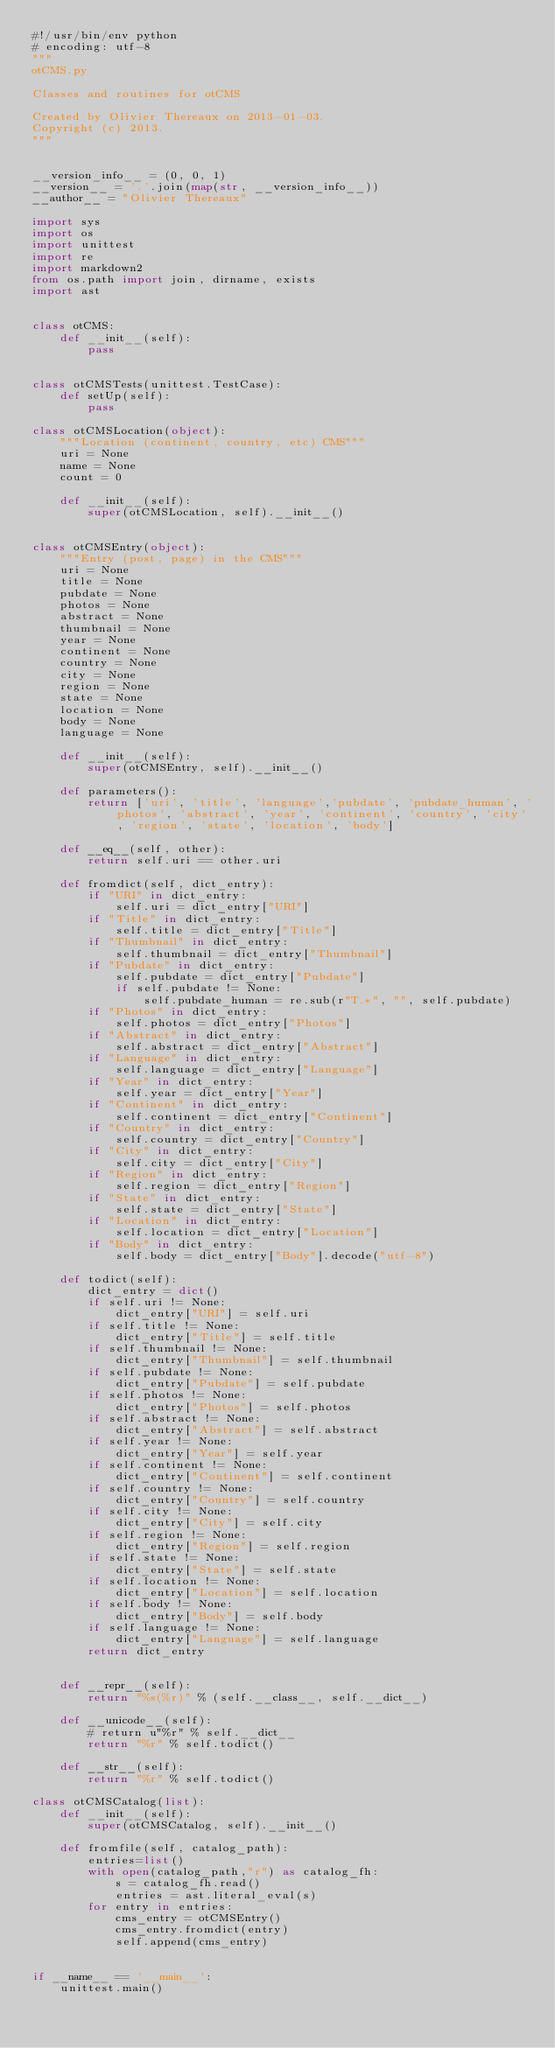Convert code to text. <code><loc_0><loc_0><loc_500><loc_500><_Python_>#!/usr/bin/env python
# encoding: utf-8
"""
otCMS.py

Classes and routines for otCMS

Created by Olivier Thereaux on 2013-01-03.
Copyright (c) 2013.
"""


__version_info__ = (0, 0, 1)
__version__ = '.'.join(map(str, __version_info__))
__author__ = "Olivier Thereaux"

import sys
import os
import unittest
import re
import markdown2
from os.path import join, dirname, exists
import ast


class otCMS:
    def __init__(self):
        pass


class otCMSTests(unittest.TestCase):
    def setUp(self):
        pass

class otCMSLocation(object):
    """Location (continent, country, etc) CMS"""
    uri = None
    name = None
    count = 0

    def __init__(self):
        super(otCMSLocation, self).__init__()


class otCMSEntry(object):
    """Entry (post, page) in the CMS"""
    uri = None
    title = None
    pubdate = None
    photos = None
    abstract = None
    thumbnail = None
    year = None
    continent = None
    country = None
    city = None
    region = None
    state = None
    location = None
    body = None
    language = None

    def __init__(self):
        super(otCMSEntry, self).__init__()

    def parameters():
        return ['uri', 'title', 'language','pubdate', 'pubdate_human', 'photos', 'abstract', 'year', 'continent', 'country', 'city', 'region', 'state', 'location', 'body']

    def __eq__(self, other):
        return self.uri == other.uri

    def fromdict(self, dict_entry):
        if "URI" in dict_entry:
            self.uri = dict_entry["URI"]
        if "Title" in dict_entry:
            self.title = dict_entry["Title"]
        if "Thumbnail" in dict_entry:
            self.thumbnail = dict_entry["Thumbnail"]
        if "Pubdate" in dict_entry:
            self.pubdate = dict_entry["Pubdate"]
            if self.pubdate != None:
                self.pubdate_human = re.sub(r"T.*", "", self.pubdate)
        if "Photos" in dict_entry:
            self.photos = dict_entry["Photos"]
        if "Abstract" in dict_entry:
            self.abstract = dict_entry["Abstract"]
        if "Language" in dict_entry:
            self.language = dict_entry["Language"]
        if "Year" in dict_entry:
            self.year = dict_entry["Year"]
        if "Continent" in dict_entry:
            self.continent = dict_entry["Continent"]
        if "Country" in dict_entry:
            self.country = dict_entry["Country"]
        if "City" in dict_entry:
            self.city = dict_entry["City"]
        if "Region" in dict_entry:
            self.region = dict_entry["Region"]
        if "State" in dict_entry:
            self.state = dict_entry["State"]
        if "Location" in dict_entry:
            self.location = dict_entry["Location"]
        if "Body" in dict_entry:
            self.body = dict_entry["Body"].decode("utf-8")

    def todict(self):
        dict_entry = dict()
        if self.uri != None:
            dict_entry["URI"] = self.uri
        if self.title != None:
            dict_entry["Title"] = self.title
        if self.thumbnail != None:
            dict_entry["Thumbnail"] = self.thumbnail
        if self.pubdate != None:
            dict_entry["Pubdate"] = self.pubdate
        if self.photos != None:
            dict_entry["Photos"] = self.photos
        if self.abstract != None:
            dict_entry["Abstract"] = self.abstract
        if self.year != None:
            dict_entry["Year"] = self.year
        if self.continent != None:
            dict_entry["Continent"] = self.continent
        if self.country != None:
            dict_entry["Country"] = self.country
        if self.city != None:
            dict_entry["City"] = self.city
        if self.region != None:
            dict_entry["Region"] = self.region
        if self.state != None:
            dict_entry["State"] = self.state
        if self.location != None:
            dict_entry["Location"] = self.location
        if self.body != None:
            dict_entry["Body"] = self.body
        if self.language != None:
            dict_entry["Language"] = self.language
        return dict_entry


    def __repr__(self):
        return "%s(%r)" % (self.__class__, self.__dict__)

    def __unicode__(self):
        # return u"%r" % self.__dict__
        return "%r" % self.todict()

    def __str__(self):
        return "%r" % self.todict()

class otCMSCatalog(list):
    def __init__(self):
        super(otCMSCatalog, self).__init__()

    def fromfile(self, catalog_path):
        entries=list()
        with open(catalog_path,"r") as catalog_fh:
            s = catalog_fh.read()
            entries = ast.literal_eval(s)
        for entry in entries:
            cms_entry = otCMSEntry()
            cms_entry.fromdict(entry)
            self.append(cms_entry)


if __name__ == '__main__':
    unittest.main()
</code> 